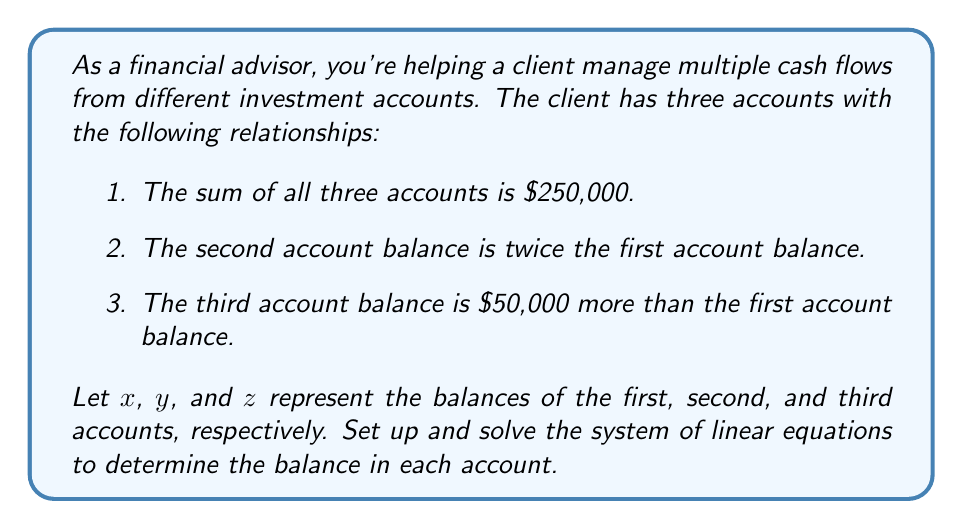Provide a solution to this math problem. Let's approach this step-by-step:

1) First, we'll set up the system of linear equations based on the given information:

   $$\begin{cases}
   x + y + z = 250,000 & \text{(sum of all accounts)}\\
   y = 2x & \text{(second account is twice the first)}\\
   z = x + 50,000 & \text{(third account is 50,000 more than the first)}
   \end{cases}$$

2) We can substitute the expressions for $y$ and $z$ into the first equation:

   $$x + 2x + (x + 50,000) = 250,000$$

3) Simplify:

   $$4x + 50,000 = 250,000$$

4) Subtract 50,000 from both sides:

   $$4x = 200,000$$

5) Divide both sides by 4:

   $$x = 50,000$$

6) Now that we know $x$, we can find $y$ and $z$:

   $y = 2x = 2(50,000) = 100,000$

   $z = x + 50,000 = 50,000 + 50,000 = 100,000$

7) Let's verify our solution:

   $$\begin{cases}
   50,000 + 100,000 + 100,000 = 250,000 & \text{(Check)}\\
   100,000 = 2(50,000) & \text{(Check)}\\
   100,000 = 50,000 + 50,000 & \text{(Check)}
   \end{cases}$$

All equations are satisfied, confirming our solution.
Answer: The balances of the three accounts are:
First account (x): $50,000
Second account (y): $100,000
Third account (z): $100,000 